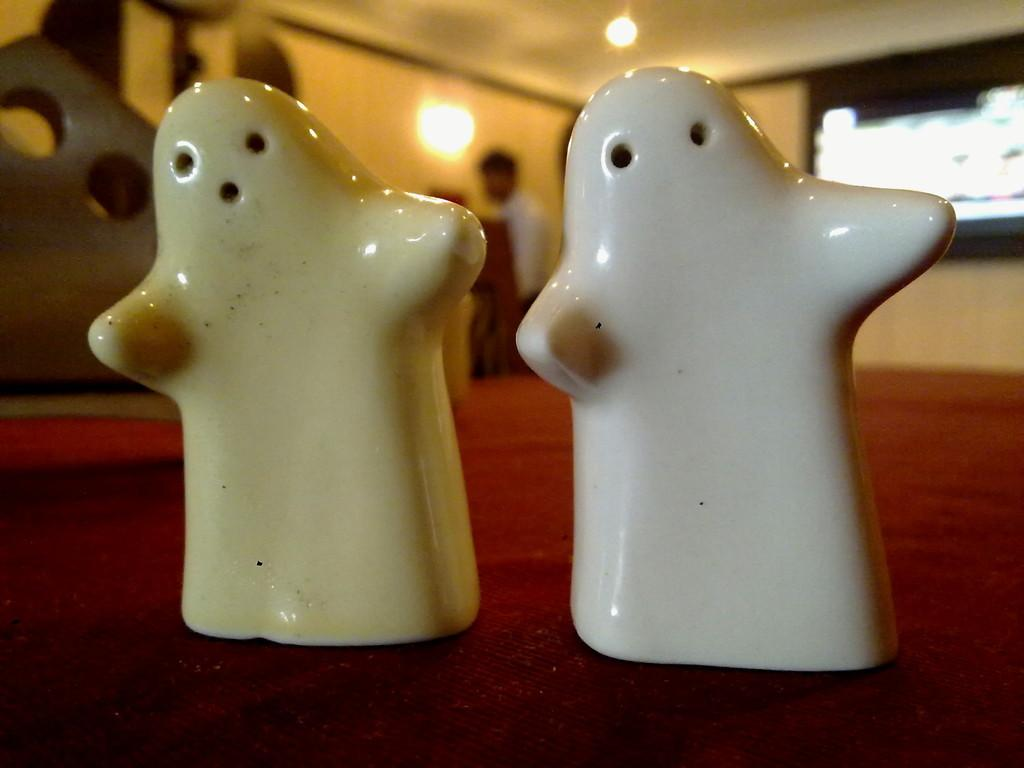How many boxes are visible in the image? There are two boxes in the image. What do the boxes resemble? The boxes resemble salt and pepper boxes. What is located at the top of the image? There are lights at the top of the image. Can you see any thumbs in the image? There are no thumbs visible in the image. What type of clouds are present in the image? There are no clouds present in the image. 